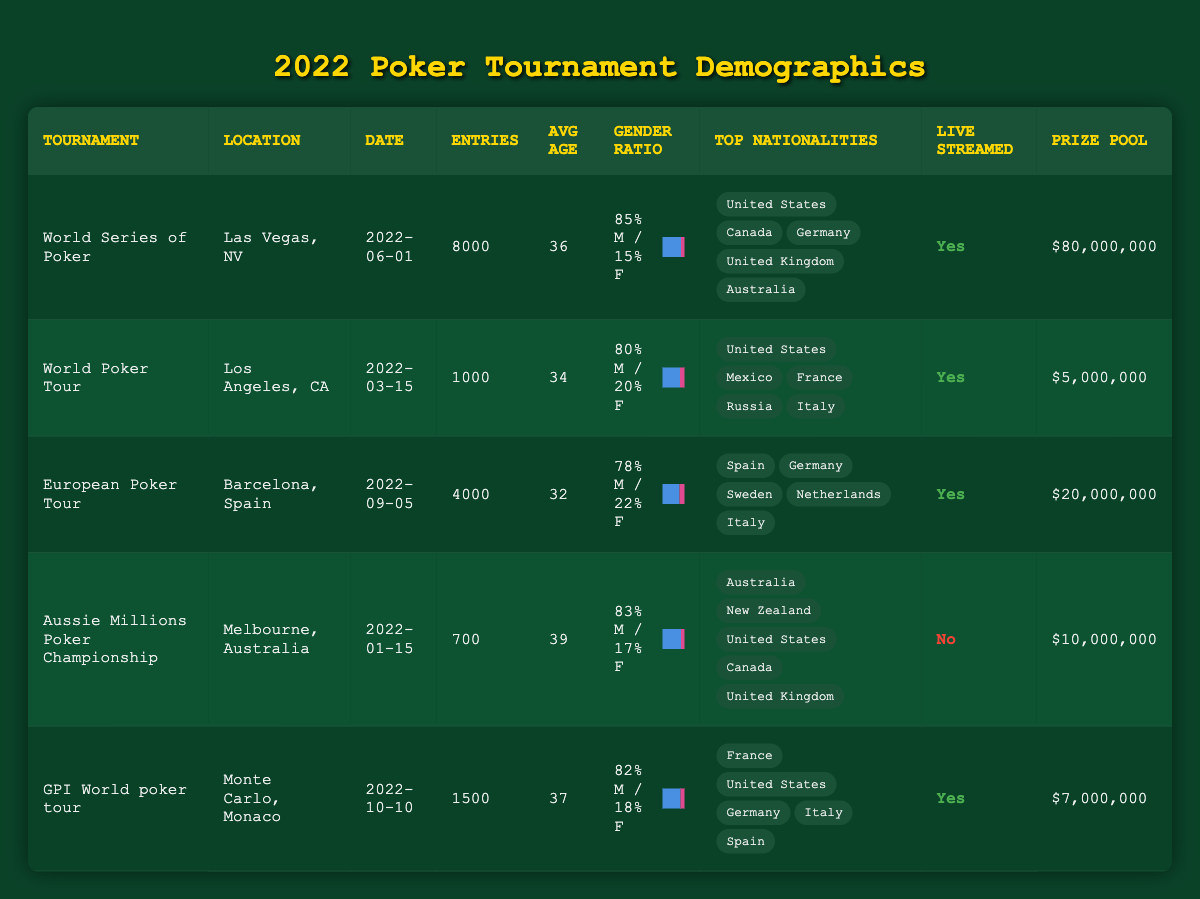What is the total number of entries across all tournaments? To find the total entries, we sum the entries from all tournaments: 8000 + 1000 + 4000 + 700 + 1500 = 10000 + 700 = 10700.
Answer: 10700 Which tournament had the highest average age of participants? By examining the average ages, we see that the highest is 39 years, which is from the Aussie Millions Poker Championship.
Answer: Aussie Millions Poker Championship What percentage of participants in the World Series of Poker were female? The gender ratio for the World Series of Poker indicates that 15% of the participants were female.
Answer: 15% How does the prize pool of the World Poker Tour compare to that of the GPI World Poker Tour? The prize pool for the World Poker Tour is $5,000,000, while for the GPI World Poker Tour it is $7,000,000. The GPI World Poker Tour has a larger prize pool by $2,000,000.
Answer: GPI World Poker Tour has a larger prize pool Is the European Poker Tour live streamed? Looking at the data for the European Poker Tour, it is confirmed that it is indeed live streamed.
Answer: Yes What is the average age of participants in the tournament with the smallest number of entries? The tournament with the smallest number of entries is the Aussie Millions Poker Championship with 700 entries. Its average age is 39 years.
Answer: 39 Which nationality had the most representation in the World Series of Poker? The top nationality in the World Series of Poker is the United States, as it is listed first in the top nationalities.
Answer: United States What is the total prize pool for all tournaments combined? To find the total prize pool, we add the prize pools for all tournaments: $80,000,000 + $5,000,000 + $20,000,000 + $10,000,000 + $7,000,000 = $122,000,000.
Answer: $122,000,000 Are there more male participants than female participants across all tournaments? From the gender ratios, it can be observed that all tournaments have a higher percentage of male participants than female participants.
Answer: Yes Which tournament had the least number of entries, and what was the prize pool for that tournament? The tournament with the least entries is the Aussie Millions Poker Championship with 700 entries, and its prize pool is $10,000,000.
Answer: Aussie Millions Poker Championship, $10,000,000 How many tournaments had an average age of 36 or higher? The tournaments with an average age of 36 or higher are the World Series of Poker (36), Aussie Millions Poker Championship (39), and GPI World Poker Tour (37). That totals to 3 tournaments.
Answer: 3 